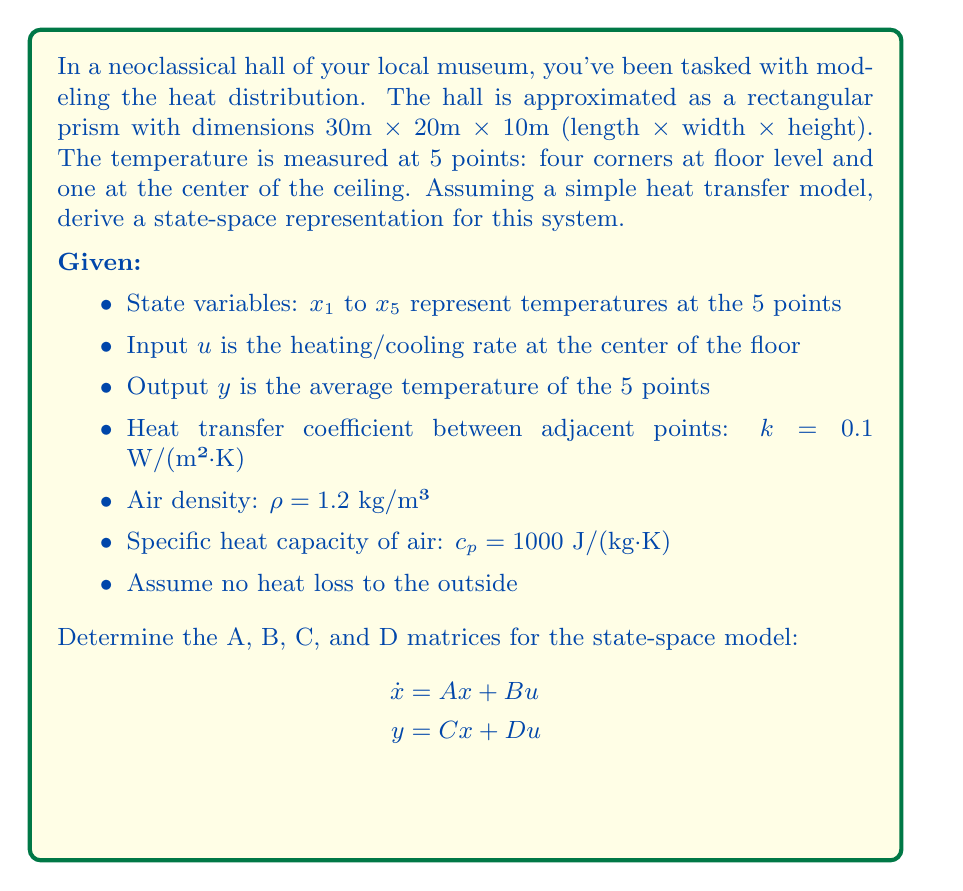Solve this math problem. To derive the state-space representation, we'll follow these steps:

1) First, let's consider the heat transfer between points. The rate of temperature change for each point will depend on the temperature difference with adjacent points and the input.

2) For the A matrix, we need to determine how each state variable changes with respect to others. The general form for each state will be:

   $\dot{x}_i = \frac{k \cdot \text{Area}}{\rho \cdot c_p \cdot \text{Volume}} \sum (x_j - x_i)$

   where j represents adjacent points.

3) Calculate the volume for each point (assuming each point represents 1/8 of the total volume for corner points, and 1/2 for the ceiling point):
   Corner points: $V_1 = V_2 = V_3 = V_4 = \frac{30 \cdot 20 \cdot 10}{8} = 750$ m³
   Ceiling point: $V_5 = \frac{30 \cdot 20 \cdot 10}{2} = 3000$ m³

4) Calculate the areas between adjacent points:
   Floor diagonal: $A_d = \sqrt{30^2 + 20^2} \cdot 10 = 360.55$ m²
   Vertical: $A_v = \frac{30 \cdot 20}{4} = 150$ m²

5) Now we can form the A matrix:

   $A = \frac{k}{\rho c_p} \begin{bmatrix}
   -\frac{2A_d+A_v}{V_1} & \frac{A_d}{V_1} & \frac{A_d}{V_1} & 0 & \frac{A_v}{V_1} \\
   \frac{A_d}{V_2} & -\frac{2A_d+A_v}{V_2} & 0 & \frac{A_d}{V_2} & \frac{A_v}{V_2} \\
   \frac{A_d}{V_3} & 0 & -\frac{2A_d+A_v}{V_3} & \frac{A_d}{V_3} & \frac{A_v}{V_3} \\
   0 & \frac{A_d}{V_4} & \frac{A_d}{V_4} & -\frac{2A_d+A_v}{V_4} & \frac{A_v}{V_4} \\
   \frac{A_v}{V_5} & \frac{A_v}{V_5} & \frac{A_v}{V_5} & \frac{A_v}{V_5} & -\frac{4A_v}{V_5}
   \end{bmatrix}$

6) For the B matrix, the input affects only the center of the floor, which we'll assume equally impacts all floor corners:

   $B = \begin{bmatrix} 0.25 \\ 0.25 \\ 0.25 \\ 0.25 \\ 0 \end{bmatrix}$

7) The C matrix for the average temperature output is:

   $C = \begin{bmatrix} 0.2 & 0.2 & 0.2 & 0.2 & 0.2 \end{bmatrix}$

8) There's no direct feed-through, so D = 0.
Answer: $A = \frac{0.1}{1.2 \cdot 1000} \begin{bmatrix}
-1.161 & 0.481 & 0.481 & 0 & 0.2 \\
0.481 & -1.161 & 0 & 0.481 & 0.2 \\
0.481 & 0 & -1.161 & 0.481 & 0.2 \\
0 & 0.481 & 0.481 & -1.161 & 0.2 \\
0.05 & 0.05 & 0.05 & 0.05 & -0.2
\end{bmatrix} \cdot 10^{-4}$, $B = \begin{bmatrix} 0.25 \\ 0.25 \\ 0.25 \\ 0.25 \\ 0 \end{bmatrix}$, $C = \begin{bmatrix} 0.2 & 0.2 & 0.2 & 0.2 & 0.2 \end{bmatrix}$, $D = 0$ 